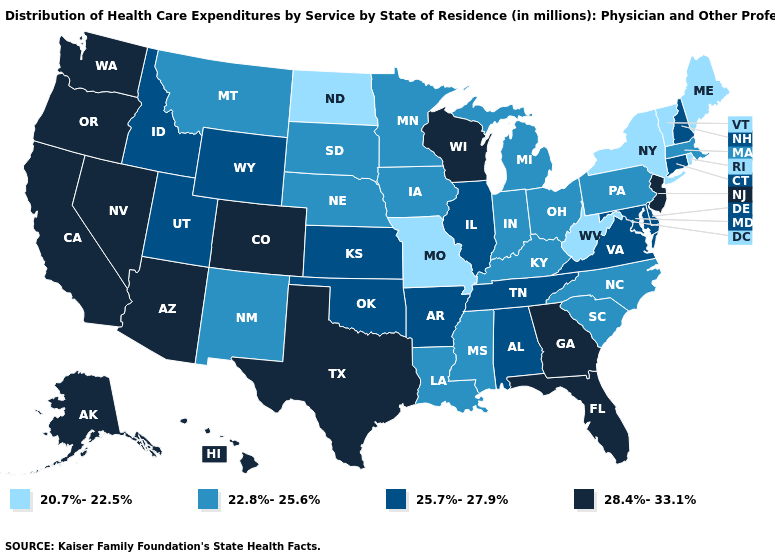Does Kansas have a lower value than Rhode Island?
Be succinct. No. What is the value of Maine?
Short answer required. 20.7%-22.5%. Name the states that have a value in the range 25.7%-27.9%?
Short answer required. Alabama, Arkansas, Connecticut, Delaware, Idaho, Illinois, Kansas, Maryland, New Hampshire, Oklahoma, Tennessee, Utah, Virginia, Wyoming. Name the states that have a value in the range 20.7%-22.5%?
Keep it brief. Maine, Missouri, New York, North Dakota, Rhode Island, Vermont, West Virginia. Does New York have the lowest value in the USA?
Concise answer only. Yes. Does Ohio have the highest value in the USA?
Quick response, please. No. What is the value of Alabama?
Be succinct. 25.7%-27.9%. Name the states that have a value in the range 22.8%-25.6%?
Keep it brief. Indiana, Iowa, Kentucky, Louisiana, Massachusetts, Michigan, Minnesota, Mississippi, Montana, Nebraska, New Mexico, North Carolina, Ohio, Pennsylvania, South Carolina, South Dakota. Does Montana have the lowest value in the West?
Give a very brief answer. Yes. Does Alabama have a higher value than Michigan?
Give a very brief answer. Yes. Among the states that border New Hampshire , does Massachusetts have the lowest value?
Write a very short answer. No. Name the states that have a value in the range 20.7%-22.5%?
Answer briefly. Maine, Missouri, New York, North Dakota, Rhode Island, Vermont, West Virginia. What is the value of Connecticut?
Quick response, please. 25.7%-27.9%. What is the lowest value in the USA?
Quick response, please. 20.7%-22.5%. Name the states that have a value in the range 20.7%-22.5%?
Keep it brief. Maine, Missouri, New York, North Dakota, Rhode Island, Vermont, West Virginia. 